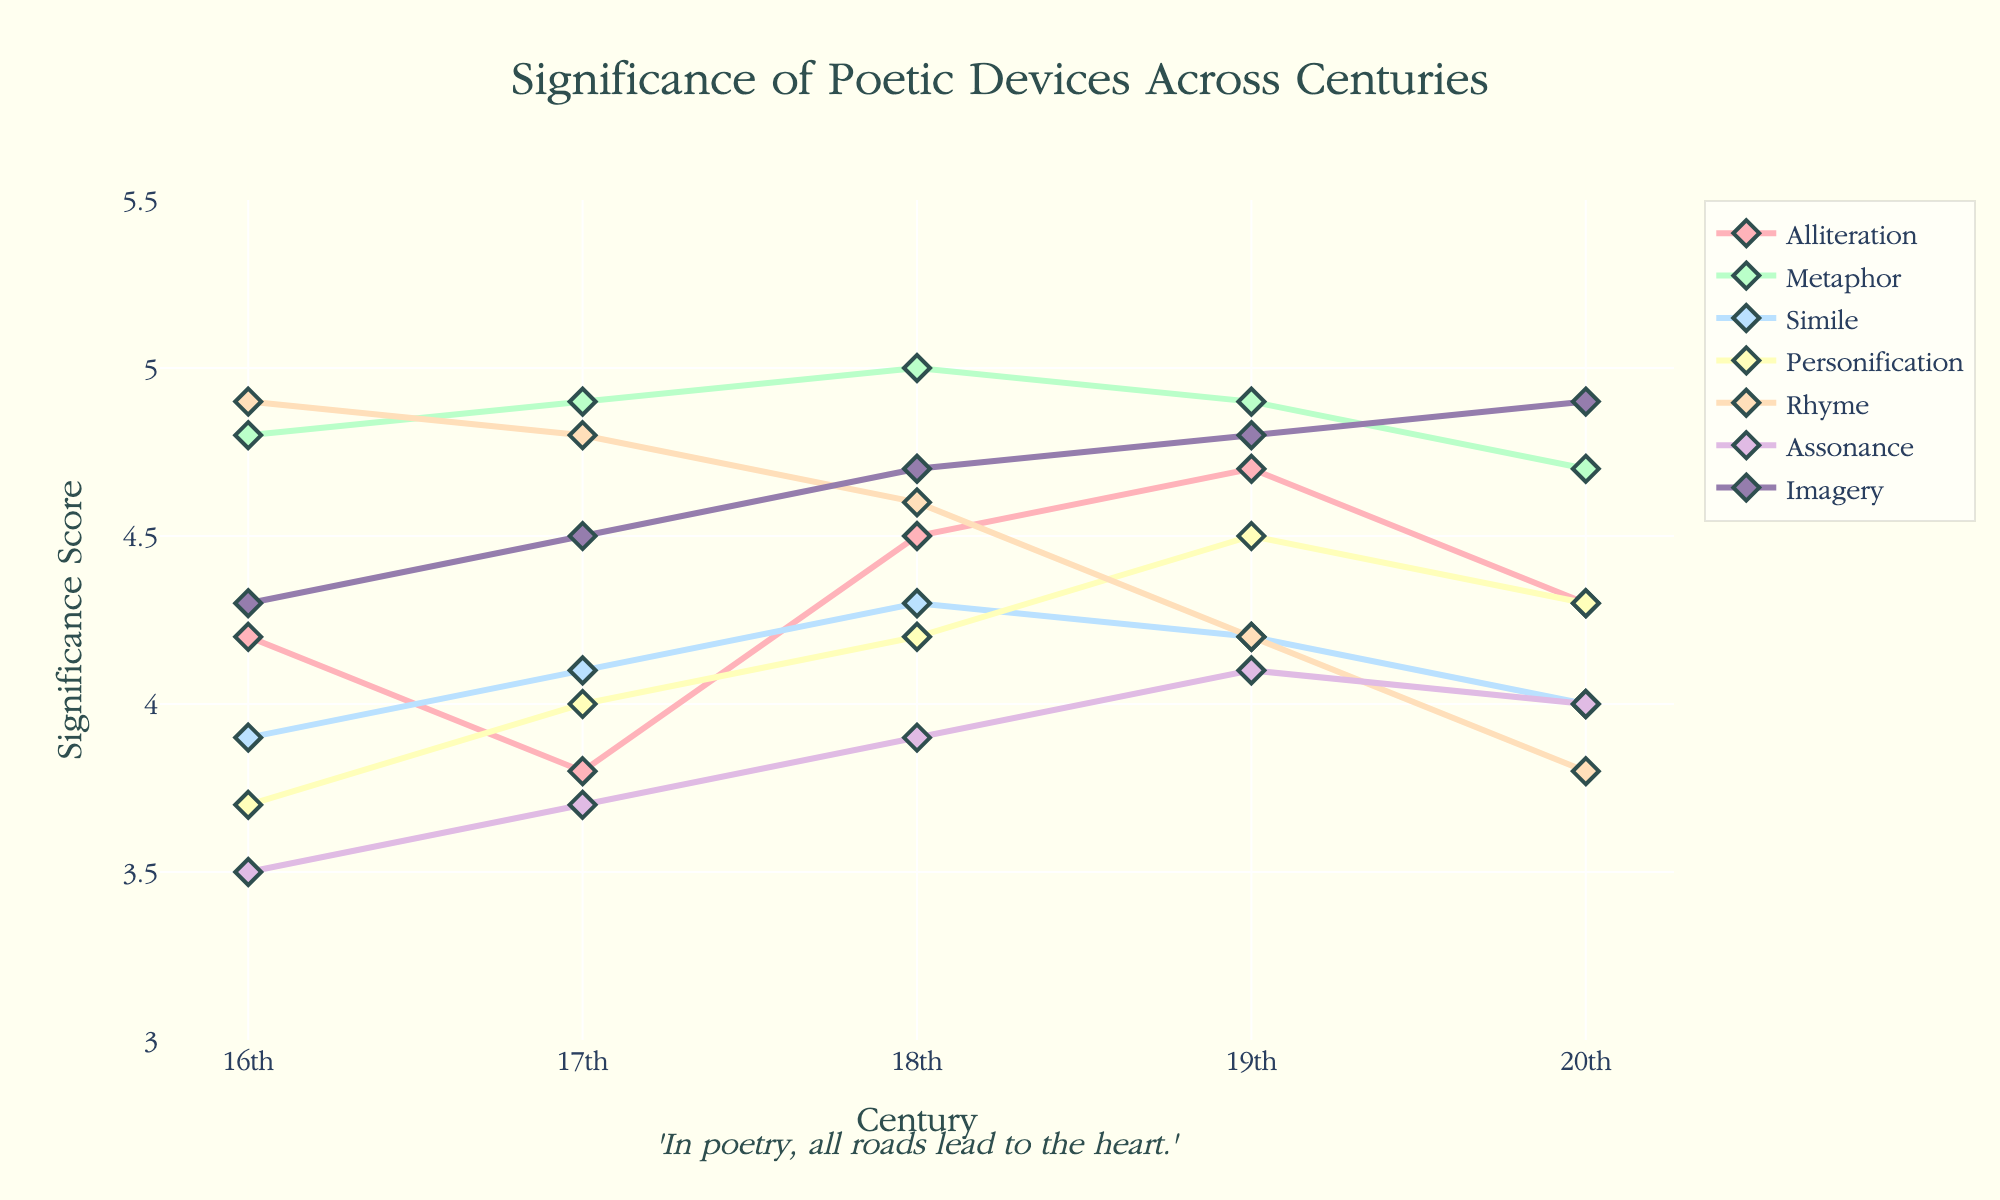What's the title of the plot? The title of the plot is prominently displayed at the top of the figure. It provides a summary of what the plot represents.
Answer: Significance of Poetic Devices Across Centuries Which poetic device has the highest significance score in the 16th century? By examining the 16th-century data points, we see that Rhyme has the highest significance score.
Answer: Rhyme How does the significance of Alliteration change from the 16th to the 20th century? Observing the trend line for Alliteration, the significance starts at 4.2 in the 16th century, dips slightly to 3.8 in the 17th century, then increases to 4.5 in the 18th, further to 4.7 in the 19th, and finally decreases to 4.3 in the 20th century.
Answer: It decreases overall What is the average significance score of Metaphor across all centuries? Add the significance scores of Metaphor (4.8, 4.9, 5.0, 4.9, and 4.7), then divide by 5. (4.8 + 4.9 + 5.0 + 4.9 + 4.7) / 5 = 24.3 / 5 = 4.86
Answer: 4.86 Which poetic device shows the most significant increase in significance score from the 16th to the 20th century? Imagery shows the most substantial increase when comparing significance scores from the 16th (4.3) to the 20th century (4.9), a change of 0.6.
Answer: Imagery Between Simile and Personification, which one has the higher significance score in the 19th century? Reviewing the significance scores for the 19th century, Simile is 4.2 and Personification is 4.5.
Answer: Personification What is the range of significance scores for Rhyme across the centuries? The highest significance score for Rhyme is 4.9 (16th century) and the lowest is 3.8 (20th century). The range is calculated as 4.9 - 3.8.
Answer: 1.1 How does the overall trend of Assonance significance scores compare to Simile? Both poetic devices saw slight increases and decreases, but Assonance has a steadier increase overall compared to Simile, which fluctuates more.
Answer: Assonance is steadier Which device among Alliteration, Metaphor, and Personification has the highest average significance score across centuries? Calculate the average significance score for each device: Alliteration (4.3), Metaphor (4.86), and Personification (4.14). Metaphor has the highest average.
Answer: Metaphor 